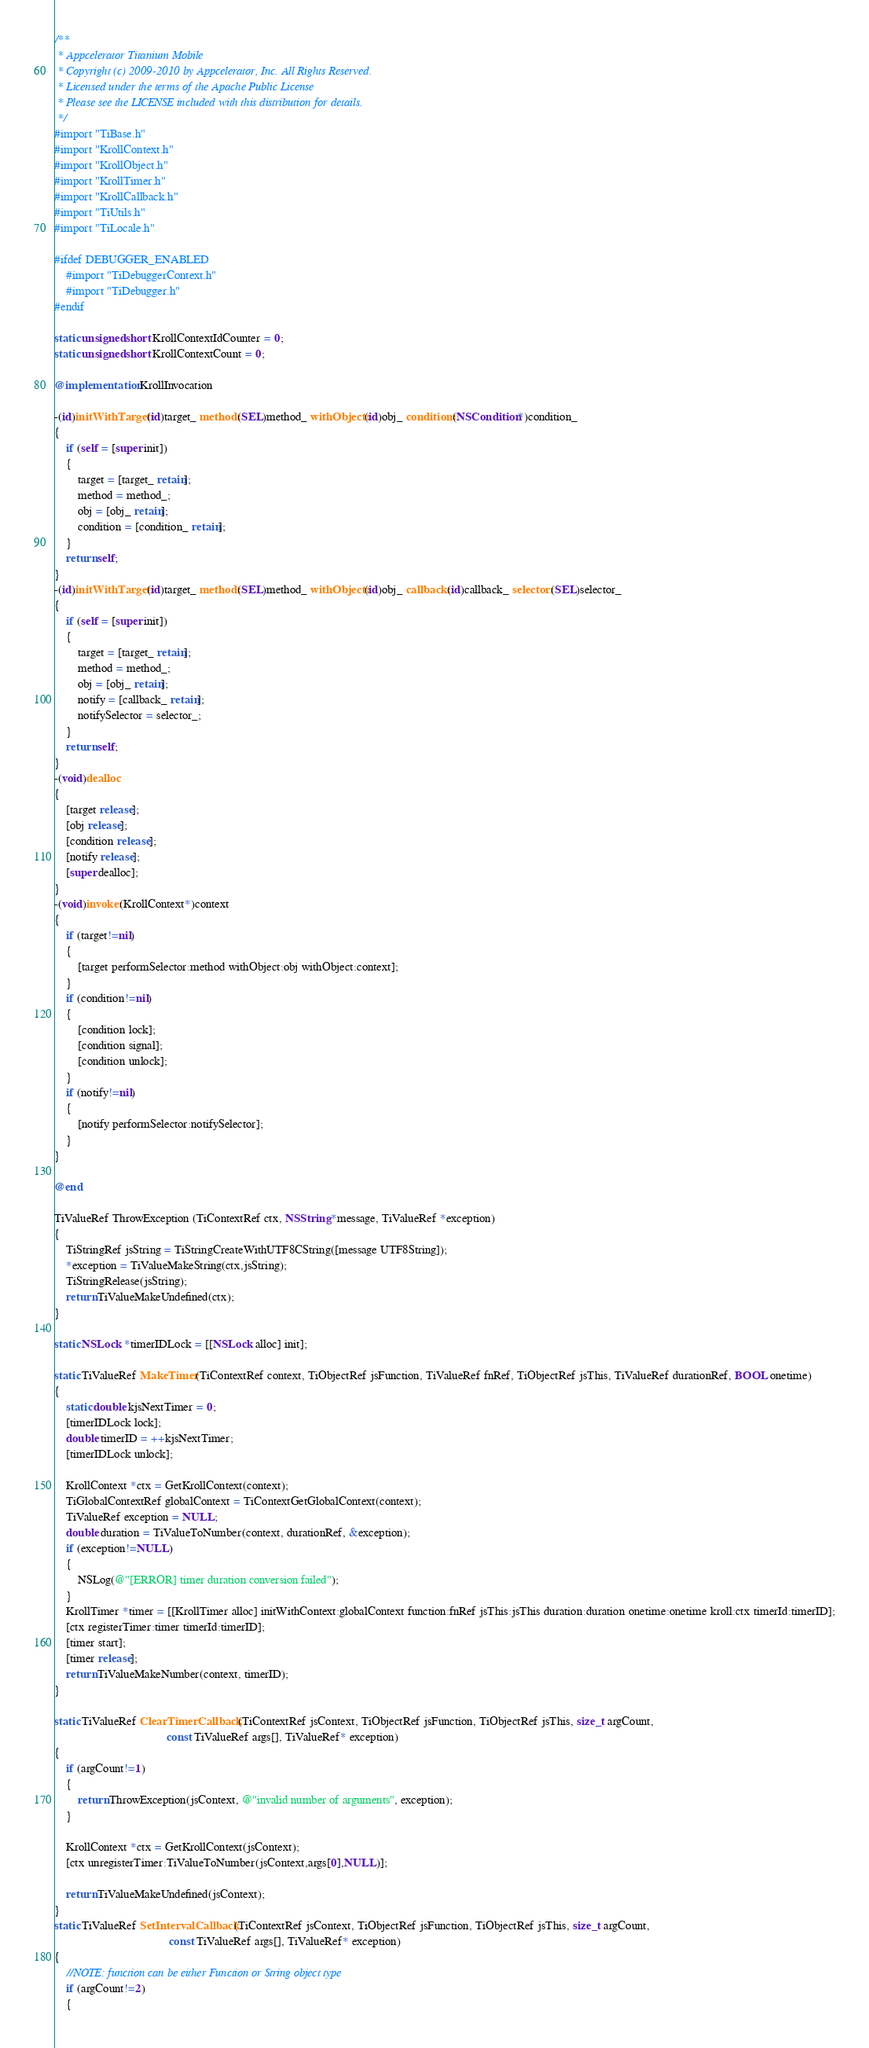Convert code to text. <code><loc_0><loc_0><loc_500><loc_500><_ObjectiveC_>/**
 * Appcelerator Titanium Mobile
 * Copyright (c) 2009-2010 by Appcelerator, Inc. All Rights Reserved.
 * Licensed under the terms of the Apache Public License
 * Please see the LICENSE included with this distribution for details.
 */
#import "TiBase.h"
#import "KrollContext.h"
#import "KrollObject.h"
#import "KrollTimer.h"
#import "KrollCallback.h"
#import "TiUtils.h"
#import "TiLocale.h"

#ifdef DEBUGGER_ENABLED
	#import "TiDebuggerContext.h"
	#import "TiDebugger.h"
#endif

static unsigned short KrollContextIdCounter = 0;
static unsigned short KrollContextCount = 0;

@implementation KrollInvocation

-(id)initWithTarget:(id)target_ method:(SEL)method_ withObject:(id)obj_ condition:(NSCondition*)condition_
{
	if (self = [super init])
	{
		target = [target_ retain];
		method = method_;
		obj = [obj_ retain];
		condition = [condition_ retain];
	}
	return self;
}
-(id)initWithTarget:(id)target_ method:(SEL)method_ withObject:(id)obj_ callback:(id)callback_ selector:(SEL)selector_
{
	if (self = [super init])
	{
		target = [target_ retain];
		method = method_;
		obj = [obj_ retain];
		notify = [callback_ retain];
		notifySelector = selector_;
	}
	return self;
}
-(void)dealloc
{
	[target release];
	[obj release];
	[condition release];
	[notify release];
	[super dealloc];
}
-(void)invoke:(KrollContext*)context
{
	if (target!=nil)
	{
		[target performSelector:method withObject:obj withObject:context];
	}
	if (condition!=nil)
	{
		[condition lock];
		[condition signal];
		[condition unlock];
	}
	if (notify!=nil)
	{
		[notify performSelector:notifySelector];
	}
}

@end

TiValueRef ThrowException (TiContextRef ctx, NSString *message, TiValueRef *exception)
{
	TiStringRef jsString = TiStringCreateWithUTF8CString([message UTF8String]);
	*exception = TiValueMakeString(ctx,jsString);
	TiStringRelease(jsString);
	return TiValueMakeUndefined(ctx);
}

static NSLock *timerIDLock = [[NSLock alloc] init];

static TiValueRef MakeTimer(TiContextRef context, TiObjectRef jsFunction, TiValueRef fnRef, TiObjectRef jsThis, TiValueRef durationRef, BOOL onetime)
{
	static double kjsNextTimer = 0;
	[timerIDLock lock];
	double timerID = ++kjsNextTimer;
	[timerIDLock unlock];
	
	KrollContext *ctx = GetKrollContext(context);
	TiGlobalContextRef globalContext = TiContextGetGlobalContext(context);
	TiValueRef exception = NULL;
	double duration = TiValueToNumber(context, durationRef, &exception);
	if (exception!=NULL)
	{
		NSLog(@"[ERROR] timer duration conversion failed");
	}
	KrollTimer *timer = [[KrollTimer alloc] initWithContext:globalContext function:fnRef jsThis:jsThis duration:duration onetime:onetime kroll:ctx timerId:timerID];
	[ctx registerTimer:timer timerId:timerID];
	[timer start];
	[timer release];
	return TiValueMakeNumber(context, timerID);
}

static TiValueRef ClearTimerCallback (TiContextRef jsContext, TiObjectRef jsFunction, TiObjectRef jsThis, size_t argCount,
									  const TiValueRef args[], TiValueRef* exception)
{
	if (argCount!=1)
	{
		return ThrowException(jsContext, @"invalid number of arguments", exception);
	}

	KrollContext *ctx = GetKrollContext(jsContext);
	[ctx unregisterTimer:TiValueToNumber(jsContext,args[0],NULL)];

	return TiValueMakeUndefined(jsContext);
}	
static TiValueRef SetIntervalCallback (TiContextRef jsContext, TiObjectRef jsFunction, TiObjectRef jsThis, size_t argCount,
									   const TiValueRef args[], TiValueRef* exception)
{
	//NOTE: function can be either Function or String object type
	if (argCount!=2)
	{</code> 